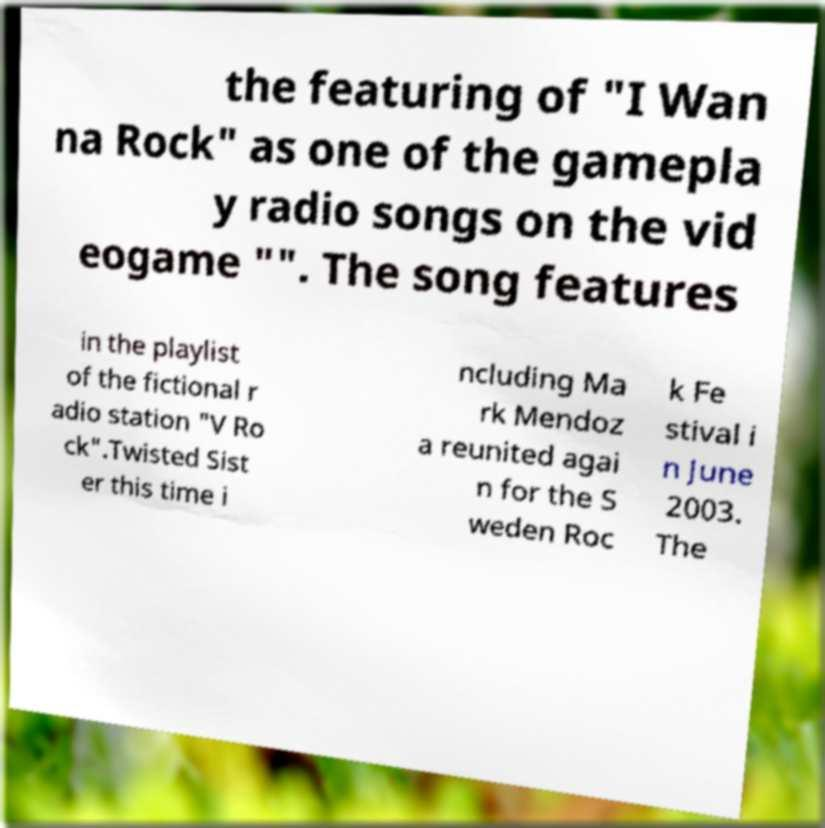Can you accurately transcribe the text from the provided image for me? the featuring of "I Wan na Rock" as one of the gamepla y radio songs on the vid eogame "". The song features in the playlist of the fictional r adio station "V Ro ck".Twisted Sist er this time i ncluding Ma rk Mendoz a reunited agai n for the S weden Roc k Fe stival i n June 2003. The 